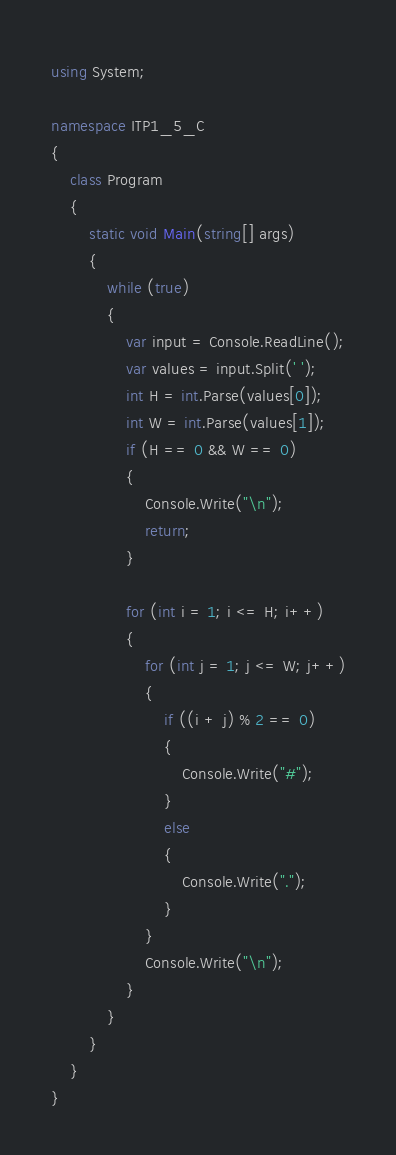Convert code to text. <code><loc_0><loc_0><loc_500><loc_500><_C#_>using System;

namespace ITP1_5_C
{
    class Program
    {
        static void Main(string[] args)
        {
            while (true)
            {
                var input = Console.ReadLine();
                var values = input.Split(' ');
                int H = int.Parse(values[0]);
                int W = int.Parse(values[1]);
                if (H == 0 && W == 0) 
                {
                    Console.Write("\n");
                    return; 
                }

                for (int i = 1; i <= H; i++)
                {
                    for (int j = 1; j <= W; j++)
                    {
                        if ((i + j) % 2 == 0)
                        {
                            Console.Write("#");
                        }
                        else
                        {
                            Console.Write(".");
                        }
                    }
                    Console.Write("\n");
                }
            }
        }
    }
}</code> 